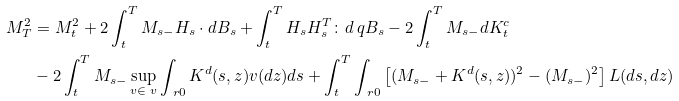<formula> <loc_0><loc_0><loc_500><loc_500>M _ { T } ^ { 2 } & = M _ { t } ^ { 2 } + 2 \int _ { t } ^ { T } M _ { s - } H _ { s } \cdot d B _ { s } + \int _ { t } ^ { T } H _ { s } H _ { s } ^ { T } \colon d \ q B _ { s } - 2 \int _ { t } ^ { T } M _ { s - } d K ^ { c } _ { t } \\ & - 2 \int _ { t } ^ { T } M _ { s - } \sup _ { v \in \ v } \int _ { \ r 0 } K ^ { d } ( s , z ) v ( d z ) d s + \int _ { t } ^ { T } \int _ { \ r 0 } \left [ ( M _ { s - } + K ^ { d } ( s , z ) ) ^ { 2 } - ( M _ { s - } ) ^ { 2 } \right ] L ( d s , d z )</formula> 